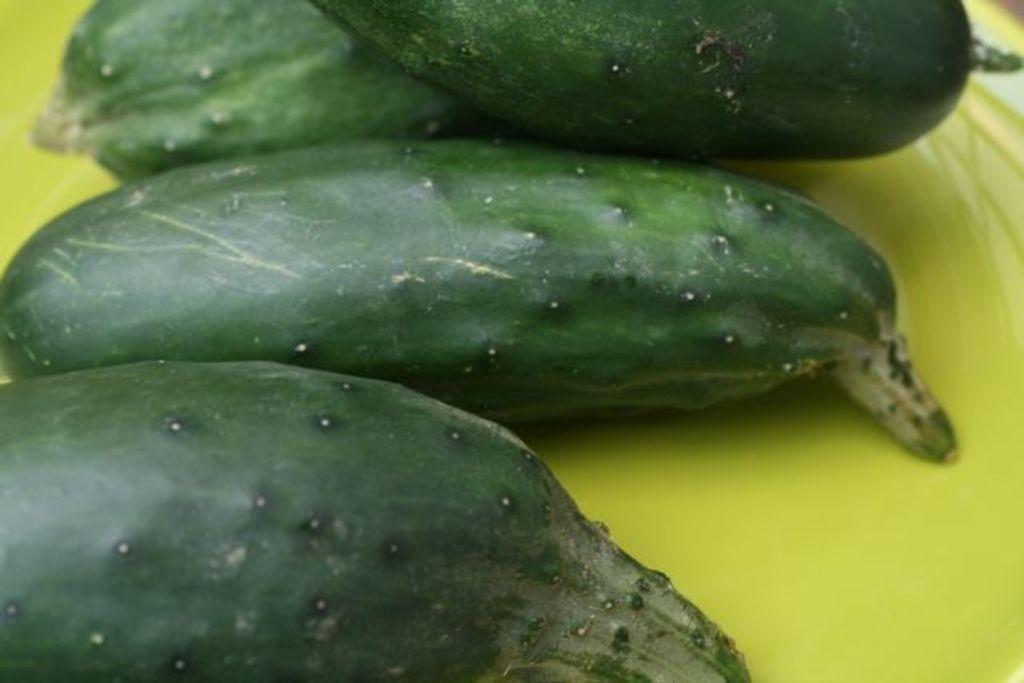What type of food can be seen in the image? There are vegetables in the image. Is there a rabbit working for peace in the image? There is no rabbit or any reference to peace or work in the image; it only features vegetables. 